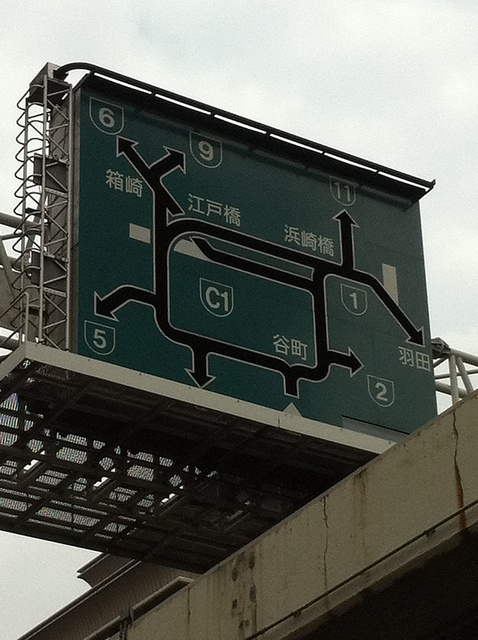Describe the objects in this image and their specific colors. I can see various objects in this image with different colors. 